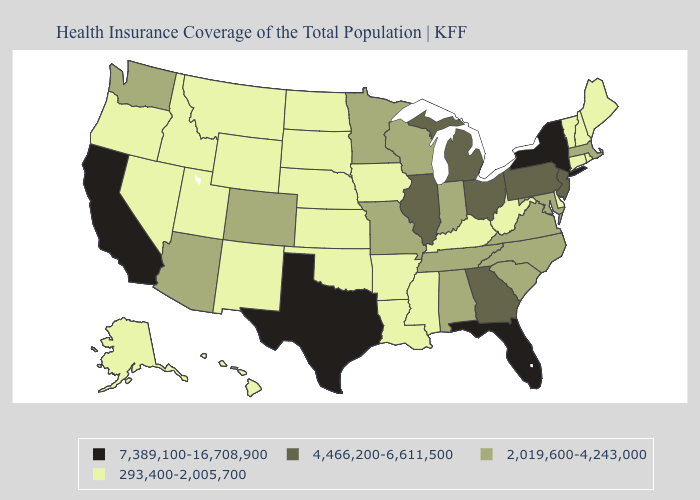Among the states that border Wisconsin , which have the highest value?
Keep it brief. Illinois, Michigan. What is the value of South Dakota?
Quick response, please. 293,400-2,005,700. Name the states that have a value in the range 293,400-2,005,700?
Keep it brief. Alaska, Arkansas, Connecticut, Delaware, Hawaii, Idaho, Iowa, Kansas, Kentucky, Louisiana, Maine, Mississippi, Montana, Nebraska, Nevada, New Hampshire, New Mexico, North Dakota, Oklahoma, Oregon, Rhode Island, South Dakota, Utah, Vermont, West Virginia, Wyoming. Which states have the lowest value in the South?
Be succinct. Arkansas, Delaware, Kentucky, Louisiana, Mississippi, Oklahoma, West Virginia. What is the value of Delaware?
Be succinct. 293,400-2,005,700. Does Texas have a lower value than Iowa?
Write a very short answer. No. Does West Virginia have the same value as Pennsylvania?
Answer briefly. No. Does Michigan have the lowest value in the MidWest?
Be succinct. No. What is the value of Minnesota?
Quick response, please. 2,019,600-4,243,000. What is the value of North Dakota?
Write a very short answer. 293,400-2,005,700. What is the highest value in states that border Montana?
Short answer required. 293,400-2,005,700. What is the value of Alaska?
Write a very short answer. 293,400-2,005,700. Does Oregon have the same value as West Virginia?
Concise answer only. Yes. What is the value of Georgia?
Quick response, please. 4,466,200-6,611,500. What is the value of Louisiana?
Quick response, please. 293,400-2,005,700. 